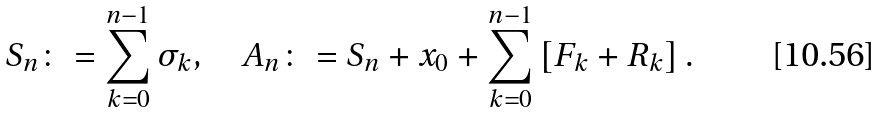<formula> <loc_0><loc_0><loc_500><loc_500>S _ { n } \colon = \sum _ { k = 0 } ^ { n - 1 } \sigma _ { k } , \quad A _ { n } \colon = S _ { n } + x _ { 0 } + \sum _ { k = 0 } ^ { n - 1 } \left [ F _ { k } + R _ { k } \right ] .</formula> 